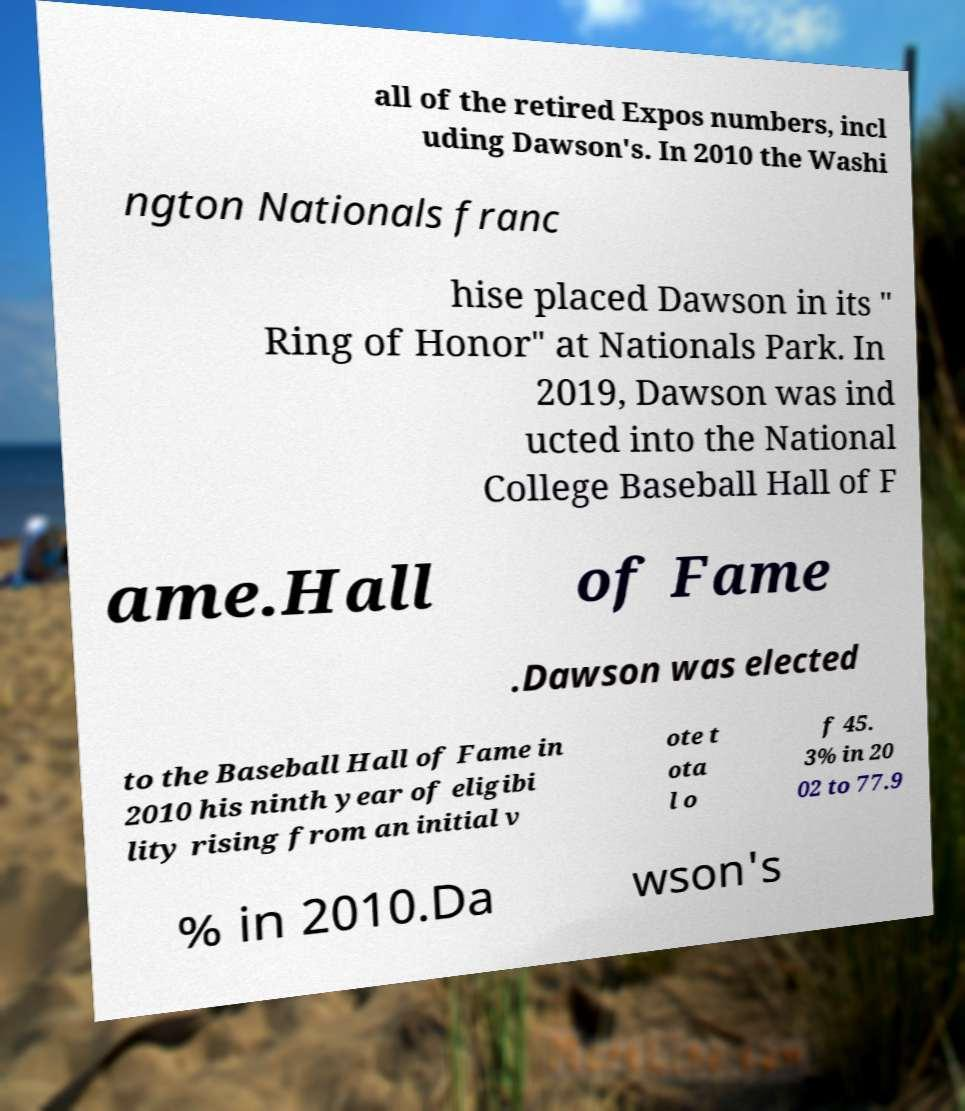What messages or text are displayed in this image? I need them in a readable, typed format. all of the retired Expos numbers, incl uding Dawson's. In 2010 the Washi ngton Nationals franc hise placed Dawson in its " Ring of Honor" at Nationals Park. In 2019, Dawson was ind ucted into the National College Baseball Hall of F ame.Hall of Fame .Dawson was elected to the Baseball Hall of Fame in 2010 his ninth year of eligibi lity rising from an initial v ote t ota l o f 45. 3% in 20 02 to 77.9 % in 2010.Da wson's 